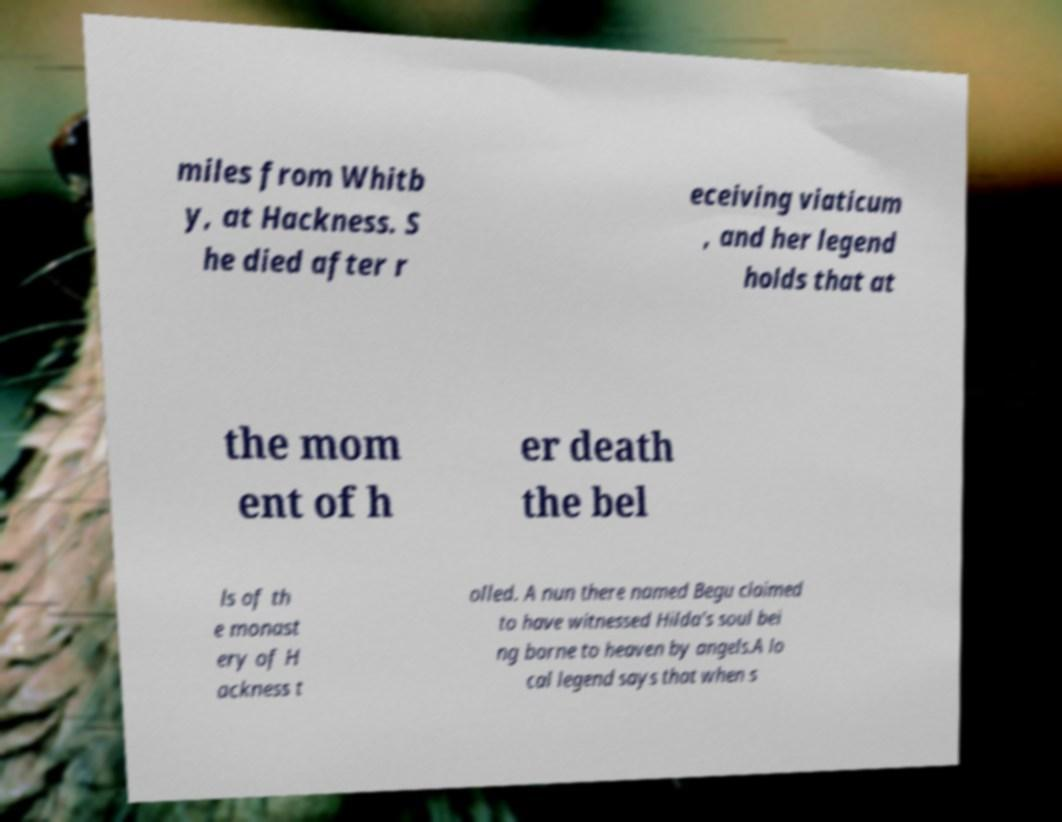Could you extract and type out the text from this image? miles from Whitb y, at Hackness. S he died after r eceiving viaticum , and her legend holds that at the mom ent of h er death the bel ls of th e monast ery of H ackness t olled. A nun there named Begu claimed to have witnessed Hilda's soul bei ng borne to heaven by angels.A lo cal legend says that when s 